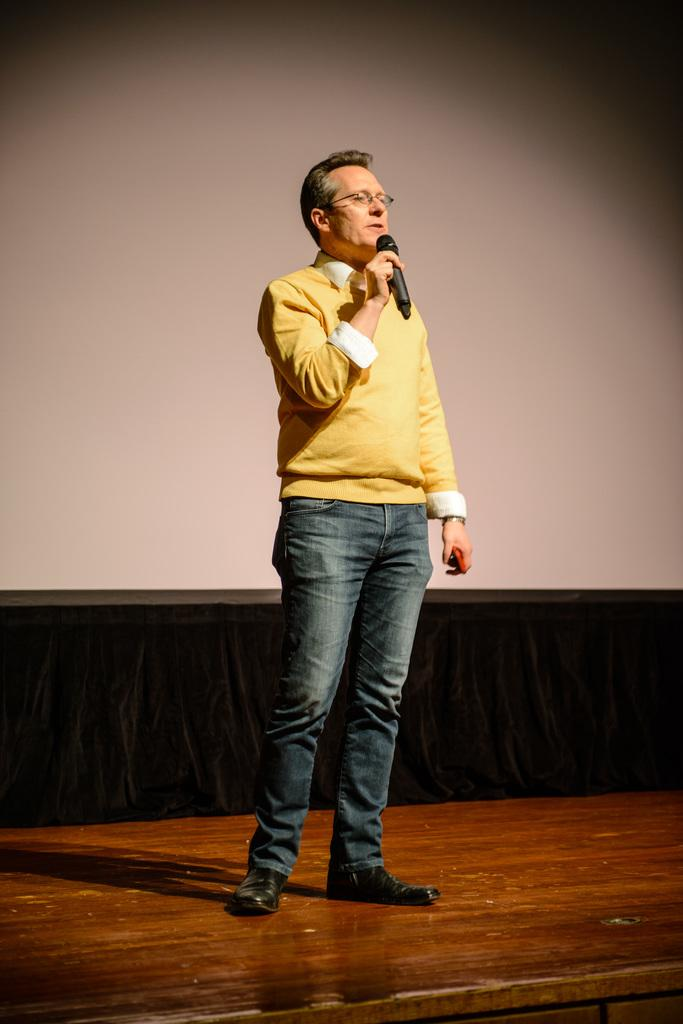What is the main subject of the image? There is a person in the image. What is the person doing in the image? The person is standing in the image. What object is the person holding in the image? The person is holding a microphone (mike) in the image. How many bees are sitting on the person's shoulder in the image? There are no bees present in the image, so it is not possible to determine the number of bees on the person's shoulder. 